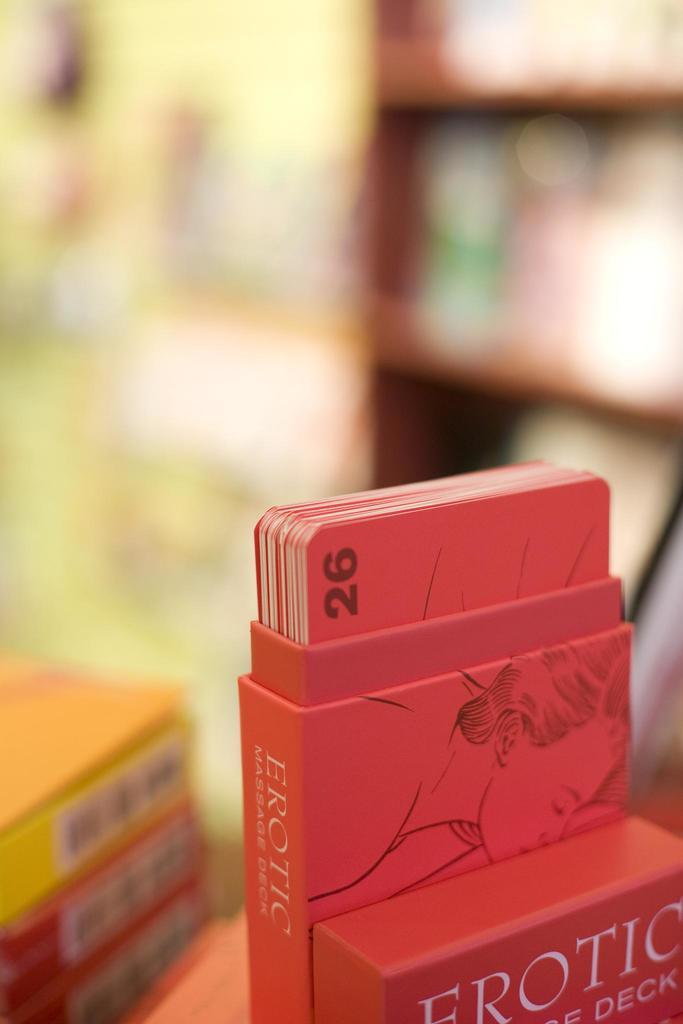<image>
Give a short and clear explanation of the subsequent image. Erotic deck of cards that have numbers wrote on it 